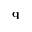Convert formula to latex. <formula><loc_0><loc_0><loc_500><loc_500>q</formula> 